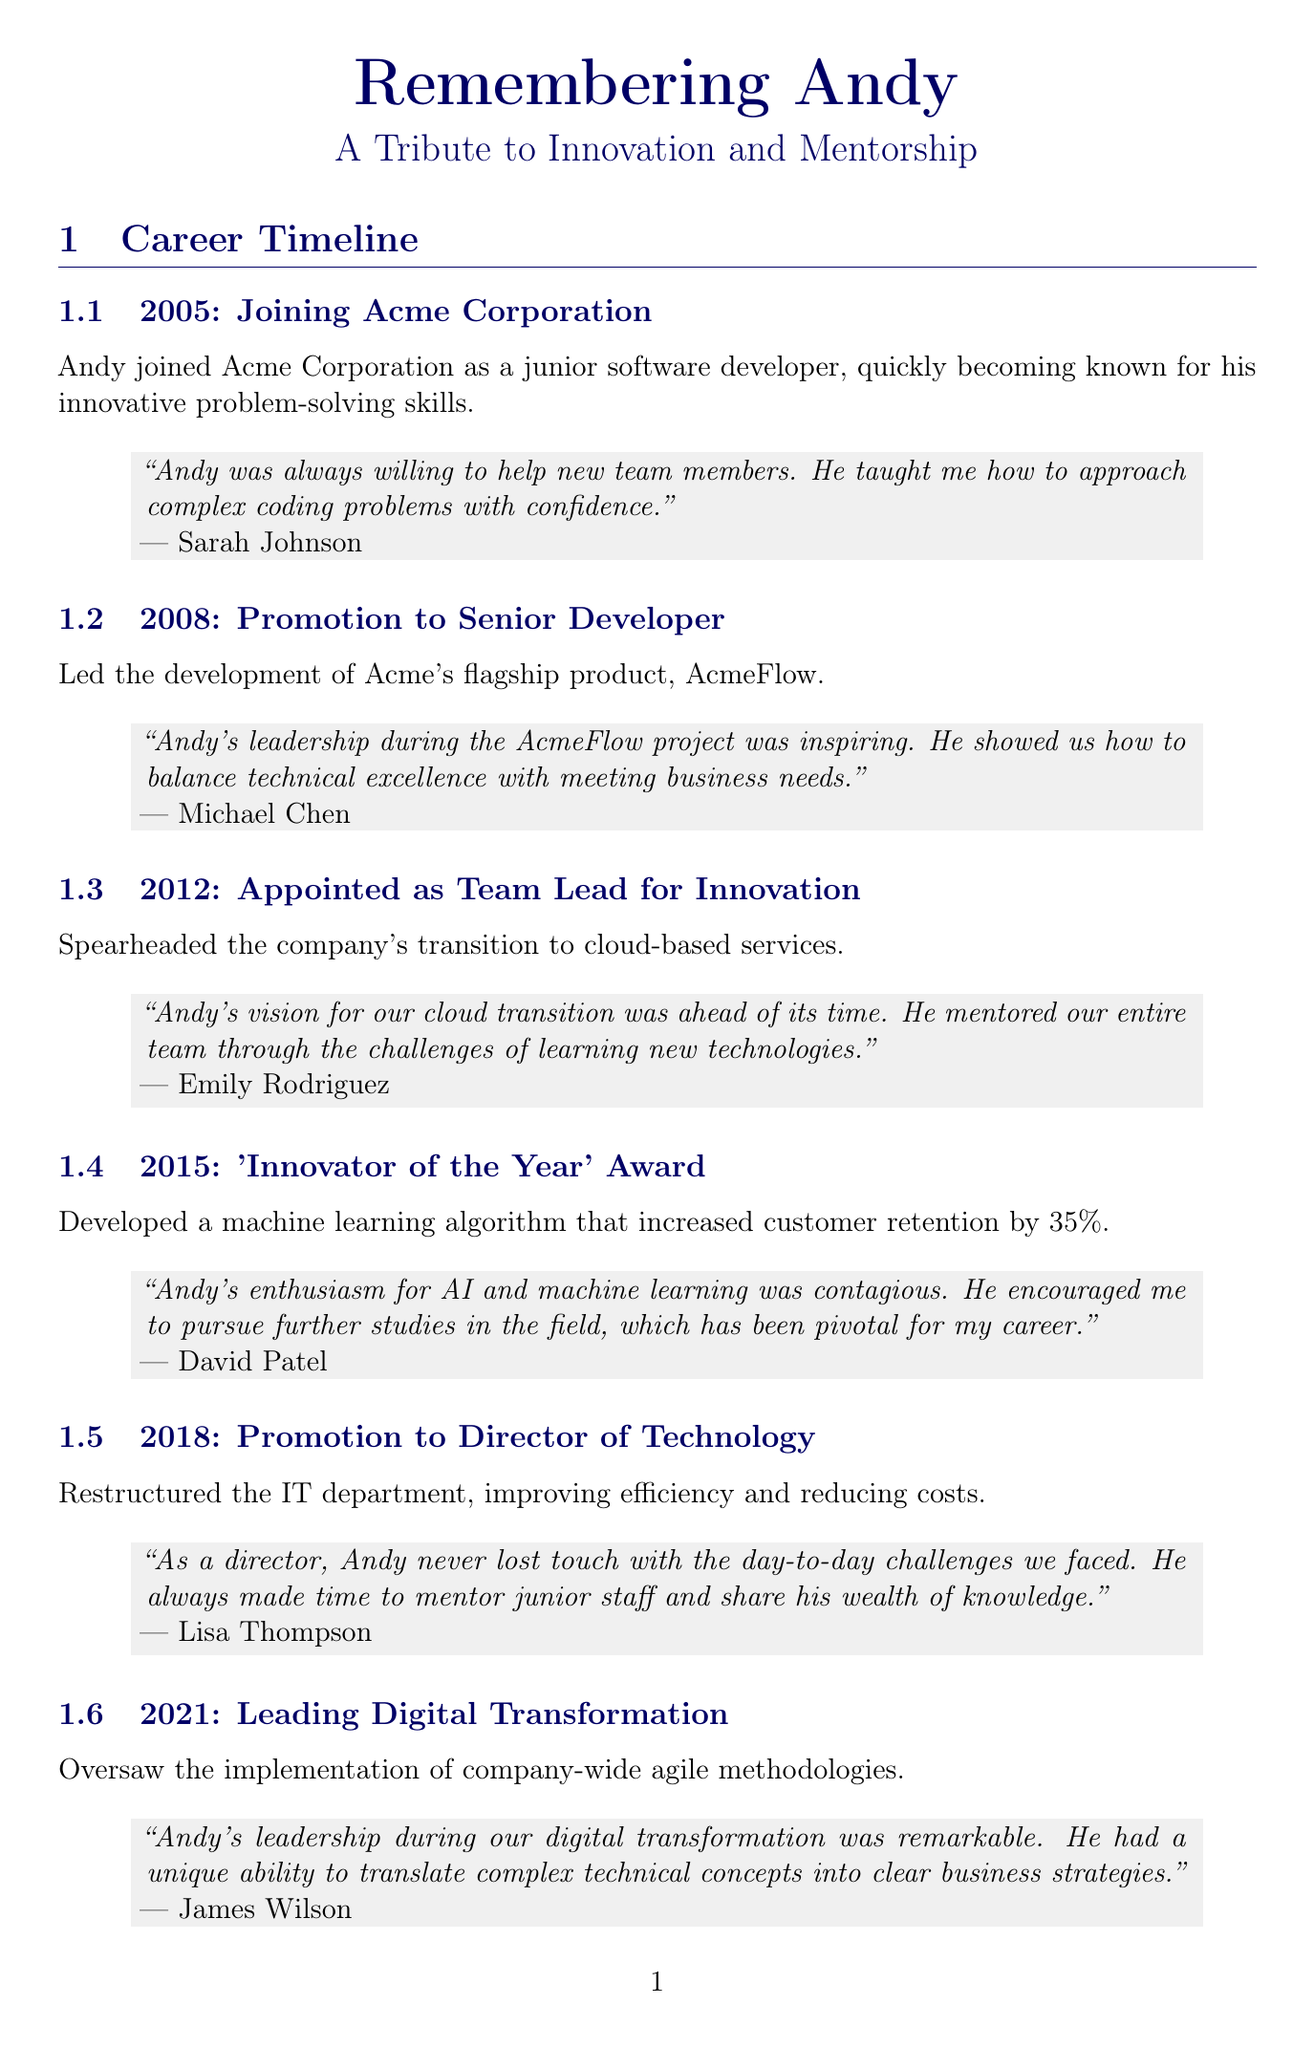What year did Andy join Acme Corporation? The year Andy joined Acme Corporation is clearly stated in the timeline entries.
Answer: 2005 What award did Andy receive in 2015? The document specifically mentions the award he received in that year as part of his achievements.
Answer: 'Innovator of the Year' Who led the development of AcmeFlow? The timeline indicates that Andy was the one who led that development during his career.
Answer: Andy How many patents did Andy file throughout his career? The total number of patents filed by Andy is mentioned in the additional achievements section.
Answer: 7 Which employee mentioned that Andy mentored their entire team? The quote for the 2012 achievement references an employee who highlighted Andy's mentorship.
Answer: Emily Rodriguez In what year did Andy lead Acme's digital transformation initiative? The timeline provides the specific year in which this initiative took place.
Answer: 2021 What initiative did Andy found in local schools? The document lists charitable initiatives that include one specifically focused on education.
Answer: 'Code for Kids' program What was one of Andy's contributions as Director of Technology? His contributions as Director of Technology are outlined in the corresponding achievement section.
Answer: Restructured the IT department Who said Andy's leadership during the digital transformation was remarkable? The quote regarding his leadership during digital transformation provides the name of the person who said this.
Answer: James Wilson 